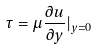<formula> <loc_0><loc_0><loc_500><loc_500>\tau = \mu \frac { \partial u } { \partial y } | _ { y = 0 }</formula> 